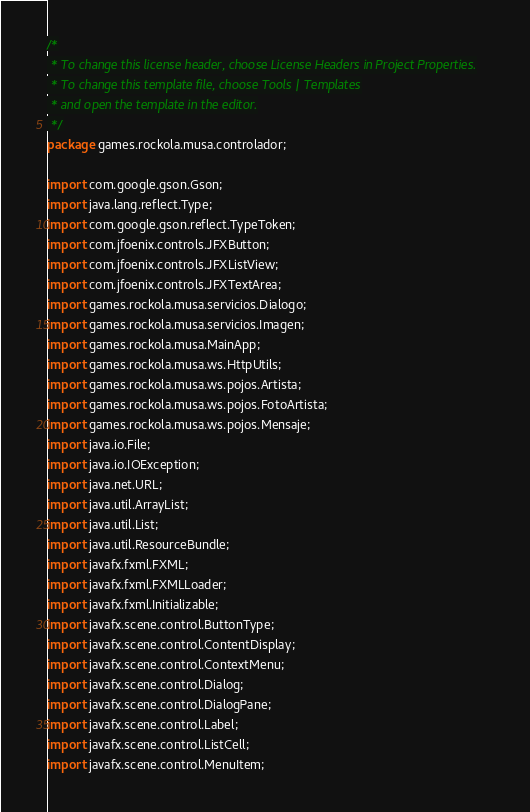<code> <loc_0><loc_0><loc_500><loc_500><_Java_>/*
 * To change this license header, choose License Headers in Project Properties.
 * To change this template file, choose Tools | Templates
 * and open the template in the editor.
 */
package games.rockola.musa.controlador;

import com.google.gson.Gson;
import java.lang.reflect.Type;
import com.google.gson.reflect.TypeToken;
import com.jfoenix.controls.JFXButton;
import com.jfoenix.controls.JFXListView;
import com.jfoenix.controls.JFXTextArea;
import games.rockola.musa.servicios.Dialogo;
import games.rockola.musa.servicios.Imagen;
import games.rockola.musa.MainApp;
import games.rockola.musa.ws.HttpUtils;
import games.rockola.musa.ws.pojos.Artista;
import games.rockola.musa.ws.pojos.FotoArtista;
import games.rockola.musa.ws.pojos.Mensaje;
import java.io.File;
import java.io.IOException;
import java.net.URL;
import java.util.ArrayList;
import java.util.List;
import java.util.ResourceBundle;
import javafx.fxml.FXML;
import javafx.fxml.FXMLLoader;
import javafx.fxml.Initializable;
import javafx.scene.control.ButtonType;
import javafx.scene.control.ContentDisplay;
import javafx.scene.control.ContextMenu;
import javafx.scene.control.Dialog;
import javafx.scene.control.DialogPane;
import javafx.scene.control.Label;
import javafx.scene.control.ListCell;
import javafx.scene.control.MenuItem;</code> 